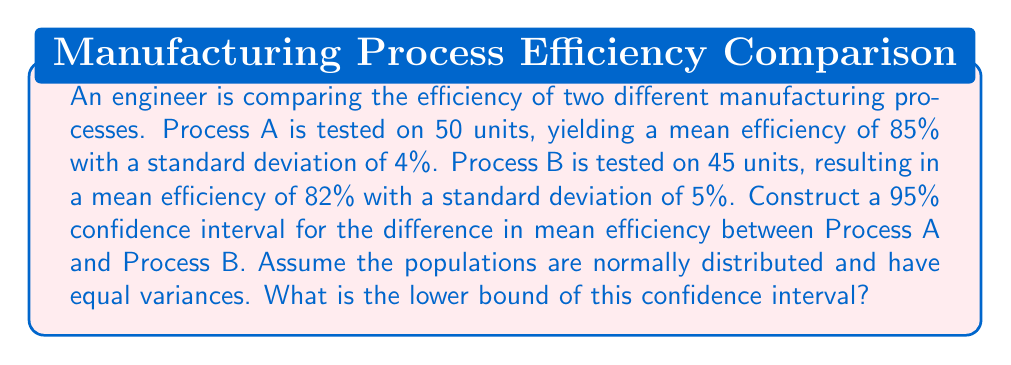Give your solution to this math problem. Let's approach this step-by-step:

1) First, we need to identify our parameters:
   $n_A = 50$, $\bar{x}_A = 85\%$, $s_A = 4\%$
   $n_B = 45$, $\bar{x}_B = 82\%$, $s_B = 5\%$
   Confidence level = 95%

2) The formula for the confidence interval is:
   $(\bar{x}_A - \bar{x}_B) \pm t_{\alpha/2} \cdot \sqrt{\frac{s_p^2}{n_A} + \frac{s_p^2}{n_B}}$

   Where $s_p^2$ is the pooled variance.

3) Calculate the pooled variance:
   $s_p^2 = \frac{(n_A - 1)s_A^2 + (n_B - 1)s_B^2}{n_A + n_B - 2}$
   $s_p^2 = \frac{(50-1)(4^2) + (45-1)(5^2)}{50 + 45 - 2} = \frac{784 + 1100}{93} = 20.26$
   $s_p = \sqrt{20.26} = 4.50\%$

4) Find $t_{\alpha/2}$:
   Degrees of freedom = $n_A + n_B - 2 = 93$
   For 95% confidence, $\alpha = 0.05$, so $t_{0.025,93} \approx 1.986$ (from t-table)

5) Calculate the margin of error:
   $ME = 1.986 \cdot \sqrt{\frac{20.26}{50} + \frac{20.26}{45}} = 1.986 \cdot 0.9376 = 1.86\%$

6) Calculate the confidence interval:
   $CI = (85\% - 82\%) \pm 1.86\%$
   $CI = 3\% \pm 1.86\%$
   $CI = (1.14\%, 4.86\%)$

7) The lower bound of the confidence interval is 1.14%.
Answer: 1.14% 